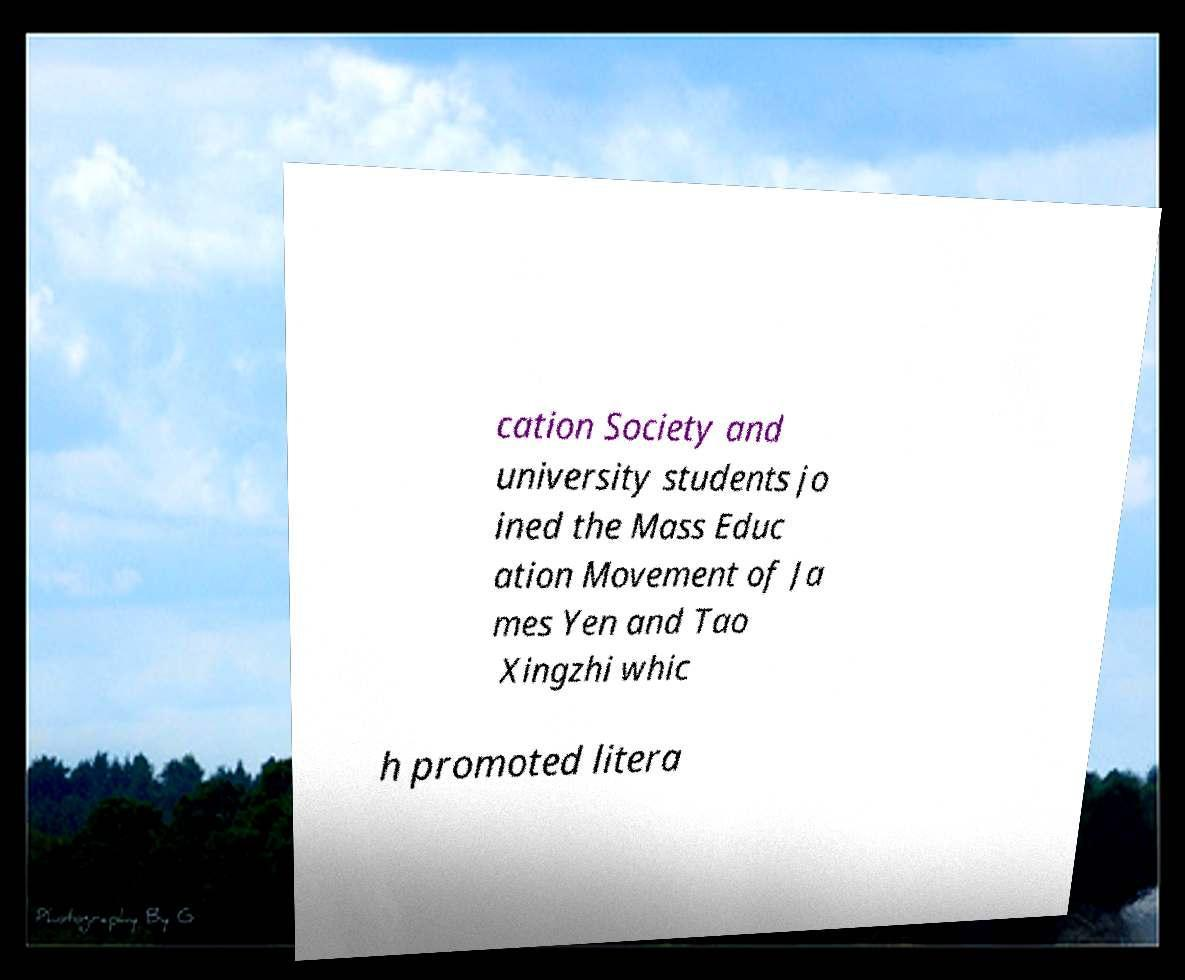What messages or text are displayed in this image? I need them in a readable, typed format. cation Society and university students jo ined the Mass Educ ation Movement of Ja mes Yen and Tao Xingzhi whic h promoted litera 